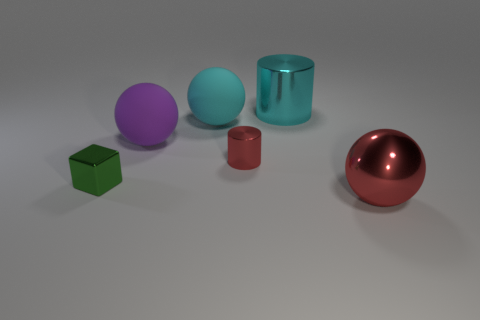Add 2 blue balls. How many objects exist? 8 Subtract all blocks. How many objects are left? 5 Subtract all large brown rubber objects. Subtract all tiny green shiny cubes. How many objects are left? 5 Add 6 tiny green shiny things. How many tiny green shiny things are left? 7 Add 6 tiny cyan shiny objects. How many tiny cyan shiny objects exist? 6 Subtract 0 yellow cubes. How many objects are left? 6 